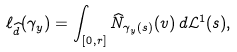Convert formula to latex. <formula><loc_0><loc_0><loc_500><loc_500>\ell _ { \widehat { d } } ( \gamma _ { y } ) = \int _ { [ 0 , r ] } \widehat { N } _ { \gamma _ { y } ( s ) } ( v ) \, d \mathcal { L } ^ { 1 } ( s ) ,</formula> 